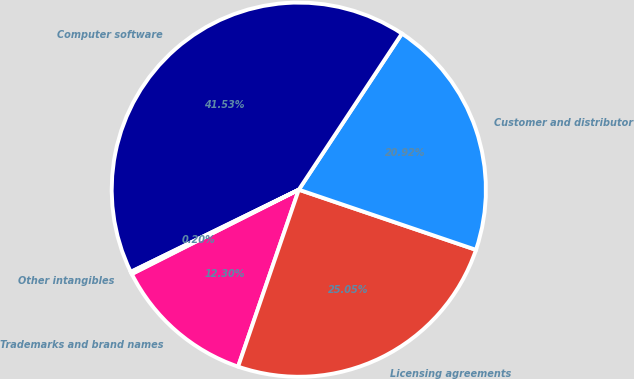<chart> <loc_0><loc_0><loc_500><loc_500><pie_chart><fcel>Trademarks and brand names<fcel>Licensing agreements<fcel>Customer and distributor<fcel>Computer software<fcel>Other intangibles<nl><fcel>12.3%<fcel>25.05%<fcel>20.92%<fcel>41.53%<fcel>0.2%<nl></chart> 